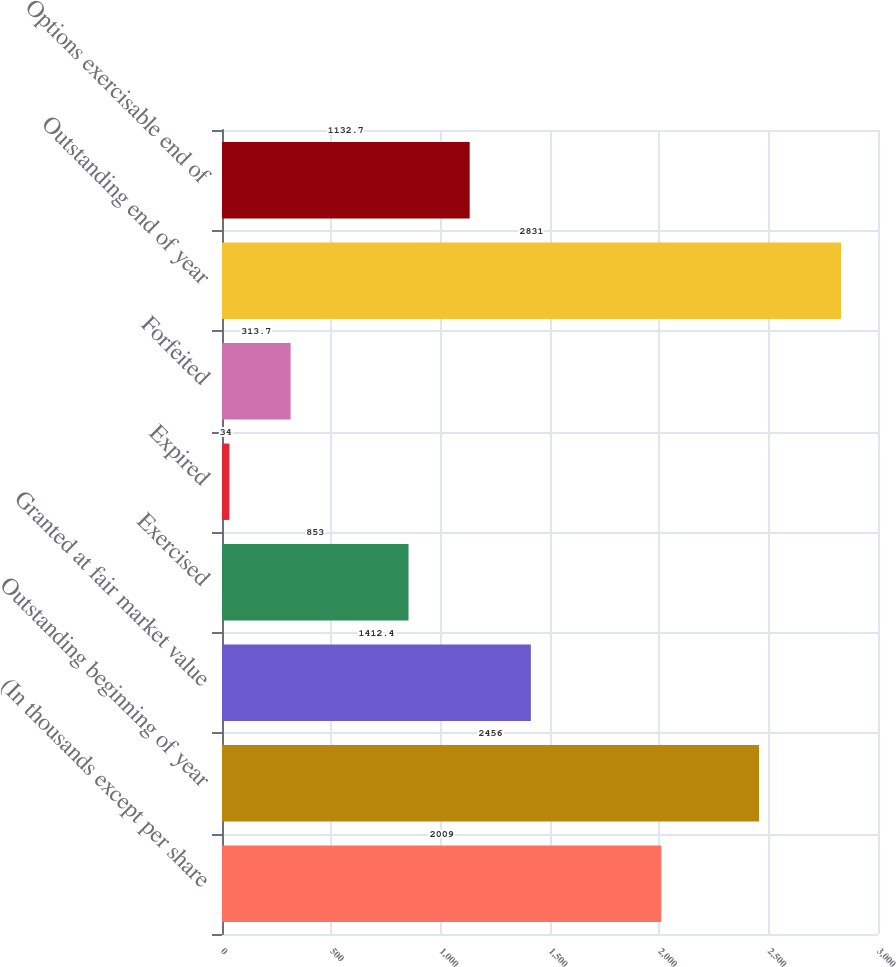Convert chart to OTSL. <chart><loc_0><loc_0><loc_500><loc_500><bar_chart><fcel>(In thousands except per share<fcel>Outstanding beginning of year<fcel>Granted at fair market value<fcel>Exercised<fcel>Expired<fcel>Forfeited<fcel>Outstanding end of year<fcel>Options exercisable end of<nl><fcel>2009<fcel>2456<fcel>1412.4<fcel>853<fcel>34<fcel>313.7<fcel>2831<fcel>1132.7<nl></chart> 